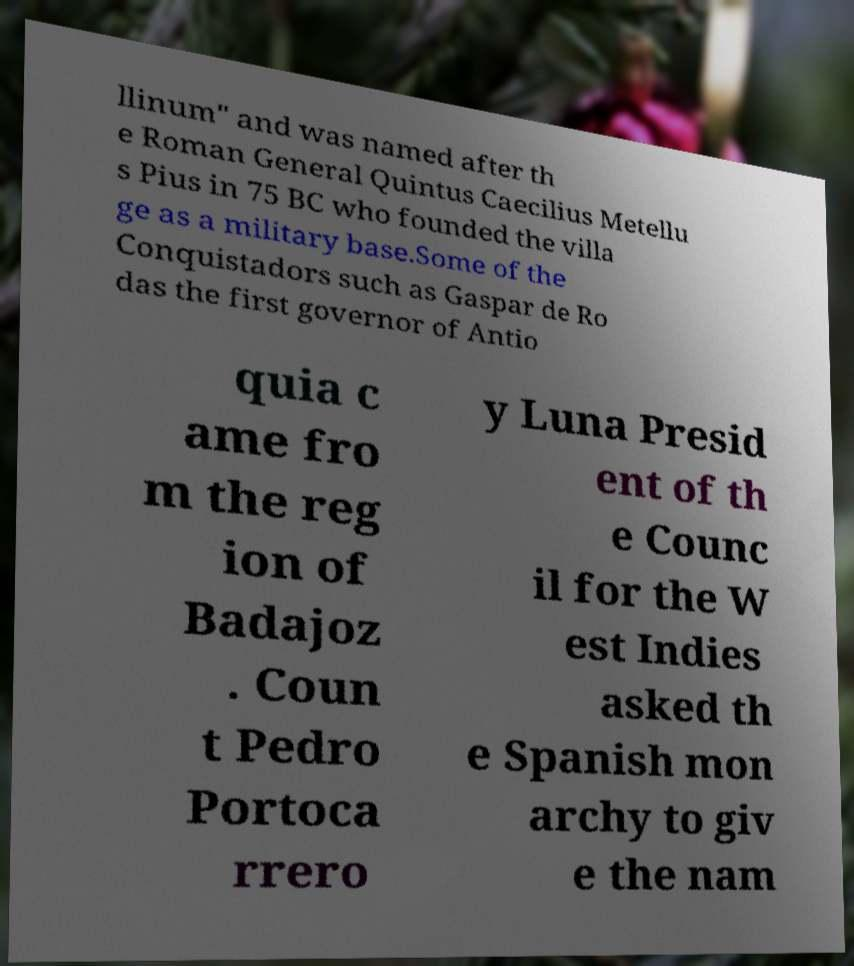What messages or text are displayed in this image? I need them in a readable, typed format. llinum" and was named after th e Roman General Quintus Caecilius Metellu s Pius in 75 BC who founded the villa ge as a military base.Some of the Conquistadors such as Gaspar de Ro das the first governor of Antio quia c ame fro m the reg ion of Badajoz . Coun t Pedro Portoca rrero y Luna Presid ent of th e Counc il for the W est Indies asked th e Spanish mon archy to giv e the nam 